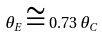<formula> <loc_0><loc_0><loc_500><loc_500>\theta _ { E } \cong 0 . 7 3 \, \theta _ { C }</formula> 